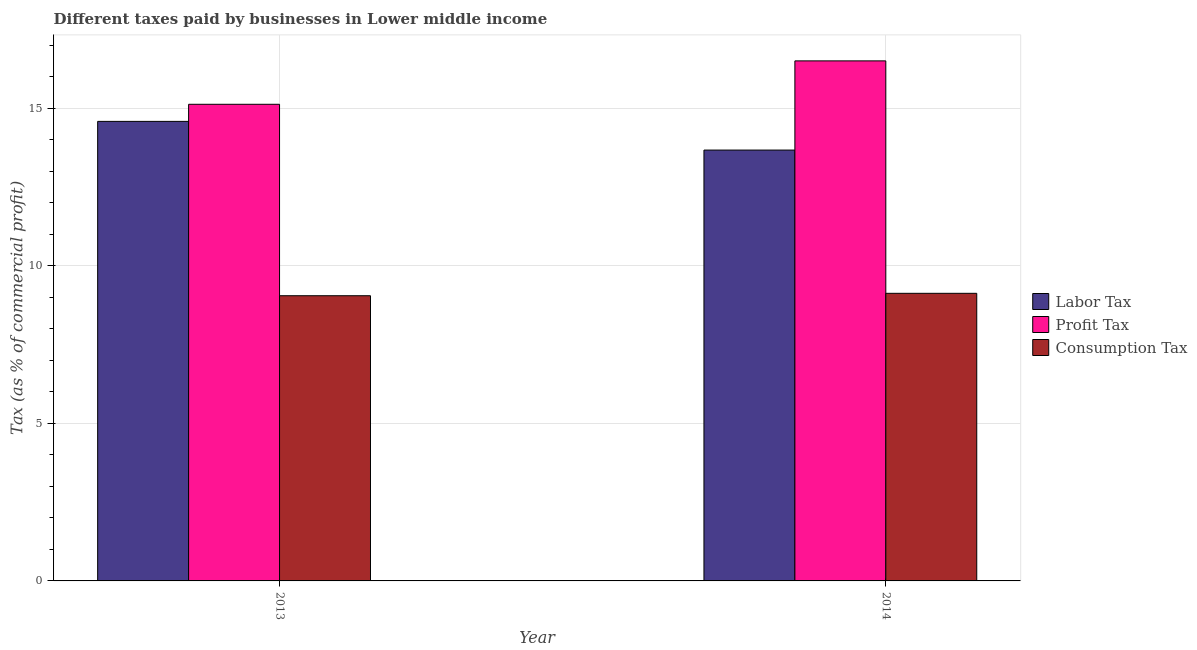How many different coloured bars are there?
Give a very brief answer. 3. Are the number of bars on each tick of the X-axis equal?
Offer a very short reply. Yes. How many bars are there on the 1st tick from the left?
Make the answer very short. 3. How many bars are there on the 1st tick from the right?
Provide a succinct answer. 3. In how many cases, is the number of bars for a given year not equal to the number of legend labels?
Provide a succinct answer. 0. What is the percentage of profit tax in 2013?
Offer a terse response. 15.12. Across all years, what is the maximum percentage of labor tax?
Make the answer very short. 14.58. Across all years, what is the minimum percentage of labor tax?
Give a very brief answer. 13.67. What is the total percentage of profit tax in the graph?
Offer a very short reply. 31.63. What is the difference between the percentage of labor tax in 2013 and that in 2014?
Ensure brevity in your answer.  0.91. What is the difference between the percentage of labor tax in 2013 and the percentage of consumption tax in 2014?
Give a very brief answer. 0.91. What is the average percentage of consumption tax per year?
Ensure brevity in your answer.  9.09. In the year 2014, what is the difference between the percentage of profit tax and percentage of labor tax?
Make the answer very short. 0. What is the ratio of the percentage of consumption tax in 2013 to that in 2014?
Provide a succinct answer. 0.99. What does the 2nd bar from the left in 2014 represents?
Keep it short and to the point. Profit Tax. What does the 3rd bar from the right in 2014 represents?
Your answer should be very brief. Labor Tax. Is it the case that in every year, the sum of the percentage of labor tax and percentage of profit tax is greater than the percentage of consumption tax?
Offer a terse response. Yes. How many bars are there?
Your answer should be compact. 6. How many years are there in the graph?
Offer a very short reply. 2. Where does the legend appear in the graph?
Keep it short and to the point. Center right. How many legend labels are there?
Provide a short and direct response. 3. What is the title of the graph?
Keep it short and to the point. Different taxes paid by businesses in Lower middle income. What is the label or title of the Y-axis?
Make the answer very short. Tax (as % of commercial profit). What is the Tax (as % of commercial profit) in Labor Tax in 2013?
Make the answer very short. 14.58. What is the Tax (as % of commercial profit) of Profit Tax in 2013?
Your answer should be compact. 15.12. What is the Tax (as % of commercial profit) in Consumption Tax in 2013?
Ensure brevity in your answer.  9.05. What is the Tax (as % of commercial profit) in Labor Tax in 2014?
Offer a terse response. 13.67. What is the Tax (as % of commercial profit) in Profit Tax in 2014?
Your response must be concise. 16.5. What is the Tax (as % of commercial profit) of Consumption Tax in 2014?
Your answer should be very brief. 9.13. Across all years, what is the maximum Tax (as % of commercial profit) in Labor Tax?
Give a very brief answer. 14.58. Across all years, what is the maximum Tax (as % of commercial profit) of Profit Tax?
Provide a short and direct response. 16.5. Across all years, what is the maximum Tax (as % of commercial profit) in Consumption Tax?
Ensure brevity in your answer.  9.13. Across all years, what is the minimum Tax (as % of commercial profit) in Labor Tax?
Make the answer very short. 13.67. Across all years, what is the minimum Tax (as % of commercial profit) of Profit Tax?
Your response must be concise. 15.12. Across all years, what is the minimum Tax (as % of commercial profit) of Consumption Tax?
Provide a short and direct response. 9.05. What is the total Tax (as % of commercial profit) in Labor Tax in the graph?
Make the answer very short. 28.25. What is the total Tax (as % of commercial profit) of Profit Tax in the graph?
Ensure brevity in your answer.  31.63. What is the total Tax (as % of commercial profit) of Consumption Tax in the graph?
Provide a succinct answer. 18.18. What is the difference between the Tax (as % of commercial profit) in Labor Tax in 2013 and that in 2014?
Provide a short and direct response. 0.91. What is the difference between the Tax (as % of commercial profit) in Profit Tax in 2013 and that in 2014?
Ensure brevity in your answer.  -1.38. What is the difference between the Tax (as % of commercial profit) in Consumption Tax in 2013 and that in 2014?
Give a very brief answer. -0.08. What is the difference between the Tax (as % of commercial profit) in Labor Tax in 2013 and the Tax (as % of commercial profit) in Profit Tax in 2014?
Ensure brevity in your answer.  -1.92. What is the difference between the Tax (as % of commercial profit) in Labor Tax in 2013 and the Tax (as % of commercial profit) in Consumption Tax in 2014?
Provide a succinct answer. 5.46. What is the difference between the Tax (as % of commercial profit) of Profit Tax in 2013 and the Tax (as % of commercial profit) of Consumption Tax in 2014?
Ensure brevity in your answer.  6. What is the average Tax (as % of commercial profit) of Labor Tax per year?
Give a very brief answer. 14.13. What is the average Tax (as % of commercial profit) of Profit Tax per year?
Make the answer very short. 15.81. What is the average Tax (as % of commercial profit) of Consumption Tax per year?
Your response must be concise. 9.09. In the year 2013, what is the difference between the Tax (as % of commercial profit) of Labor Tax and Tax (as % of commercial profit) of Profit Tax?
Provide a short and direct response. -0.54. In the year 2013, what is the difference between the Tax (as % of commercial profit) in Labor Tax and Tax (as % of commercial profit) in Consumption Tax?
Ensure brevity in your answer.  5.53. In the year 2013, what is the difference between the Tax (as % of commercial profit) of Profit Tax and Tax (as % of commercial profit) of Consumption Tax?
Provide a succinct answer. 6.07. In the year 2014, what is the difference between the Tax (as % of commercial profit) of Labor Tax and Tax (as % of commercial profit) of Profit Tax?
Provide a short and direct response. -2.83. In the year 2014, what is the difference between the Tax (as % of commercial profit) in Labor Tax and Tax (as % of commercial profit) in Consumption Tax?
Keep it short and to the point. 4.55. In the year 2014, what is the difference between the Tax (as % of commercial profit) in Profit Tax and Tax (as % of commercial profit) in Consumption Tax?
Ensure brevity in your answer.  7.38. What is the ratio of the Tax (as % of commercial profit) in Labor Tax in 2013 to that in 2014?
Give a very brief answer. 1.07. What is the ratio of the Tax (as % of commercial profit) in Profit Tax in 2013 to that in 2014?
Offer a very short reply. 0.92. What is the difference between the highest and the second highest Tax (as % of commercial profit) in Labor Tax?
Keep it short and to the point. 0.91. What is the difference between the highest and the second highest Tax (as % of commercial profit) of Profit Tax?
Make the answer very short. 1.38. What is the difference between the highest and the second highest Tax (as % of commercial profit) of Consumption Tax?
Offer a very short reply. 0.08. What is the difference between the highest and the lowest Tax (as % of commercial profit) of Labor Tax?
Offer a terse response. 0.91. What is the difference between the highest and the lowest Tax (as % of commercial profit) of Profit Tax?
Give a very brief answer. 1.38. What is the difference between the highest and the lowest Tax (as % of commercial profit) of Consumption Tax?
Make the answer very short. 0.08. 